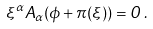<formula> <loc_0><loc_0><loc_500><loc_500>\xi ^ { \alpha } A _ { \alpha } ( \phi + \pi ( \xi ) ) = 0 \, .</formula> 